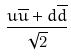<formula> <loc_0><loc_0><loc_500><loc_500>\frac { u \overline { u } + d \overline { d } } { \sqrt { 2 } }</formula> 